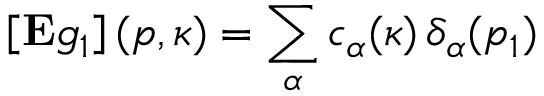<formula> <loc_0><loc_0><loc_500><loc_500>\left [ E g _ { 1 } \right ] ( p , \kappa ) = \sum _ { \alpha } c _ { \alpha } ( \kappa ) \, \delta _ { \alpha } ( p _ { 1 } )</formula> 